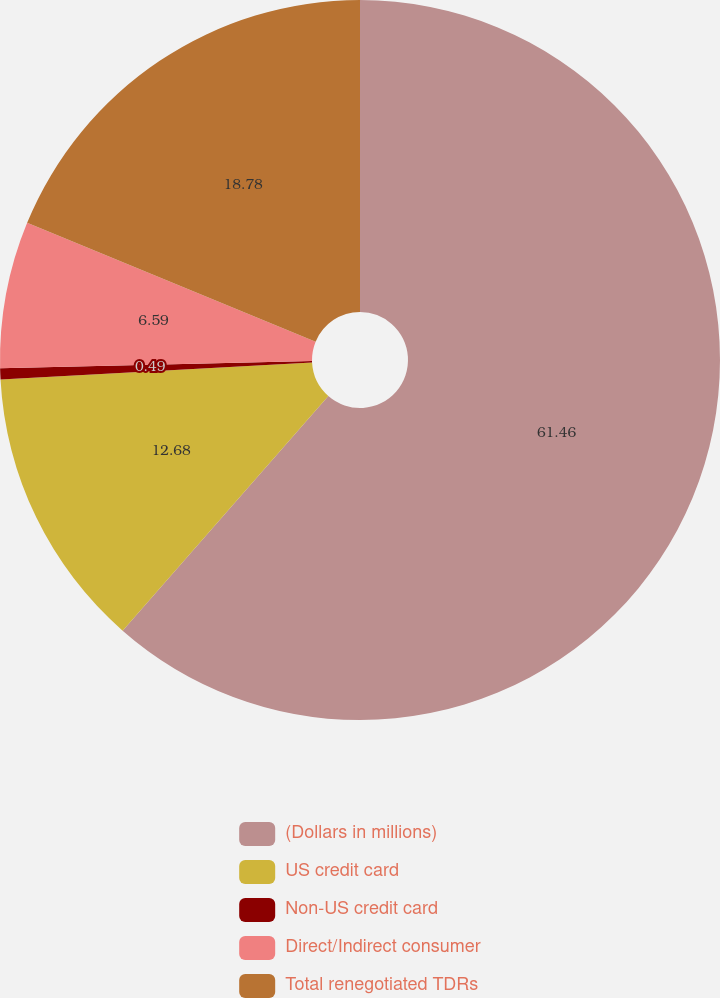<chart> <loc_0><loc_0><loc_500><loc_500><pie_chart><fcel>(Dollars in millions)<fcel>US credit card<fcel>Non-US credit card<fcel>Direct/Indirect consumer<fcel>Total renegotiated TDRs<nl><fcel>61.46%<fcel>12.68%<fcel>0.49%<fcel>6.59%<fcel>18.78%<nl></chart> 